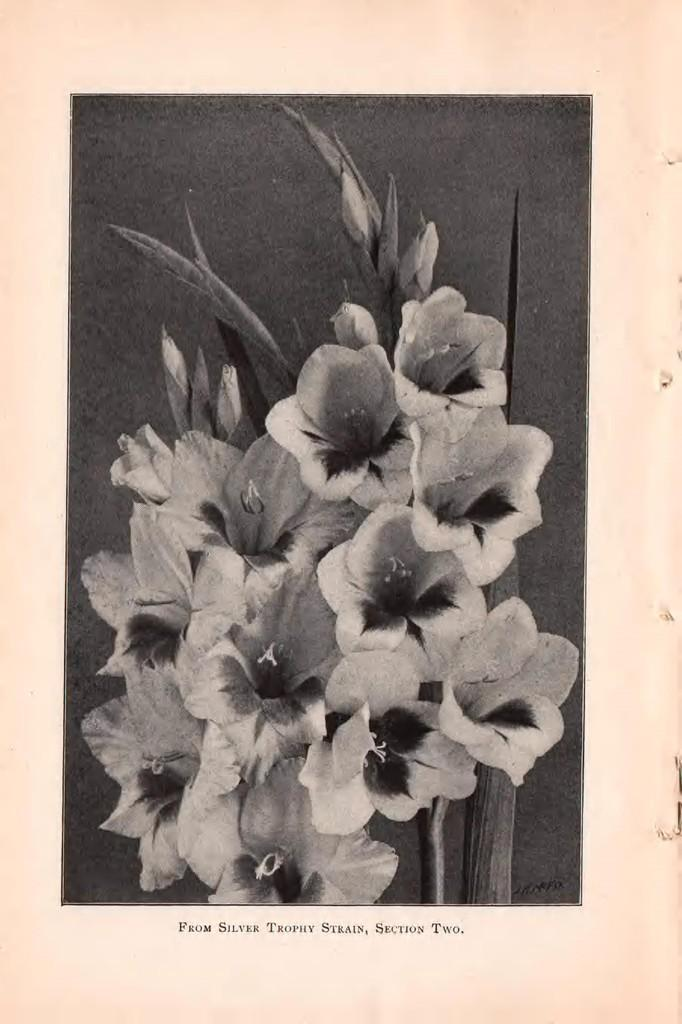What is the color scheme of the image? The image is black and white. What can be found in the center of the image? There are flowers and leaves in the center of the image. Is there any text present in the image? Yes, there is text at the bottom of the image. How many units are visible on the sidewalk in the image? There is no sidewalk or units present in the image. What type of loss is depicted in the image? There is no loss depicted in the image; it features flowers, leaves, and text. 